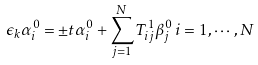Convert formula to latex. <formula><loc_0><loc_0><loc_500><loc_500>\epsilon _ { k } \alpha _ { i } ^ { 0 } = \pm t \alpha _ { i } ^ { 0 } + \sum _ { j = 1 } ^ { N } T ^ { 1 } _ { i j } \beta _ { j } ^ { 0 } \, i = 1 , \cdots , N</formula> 